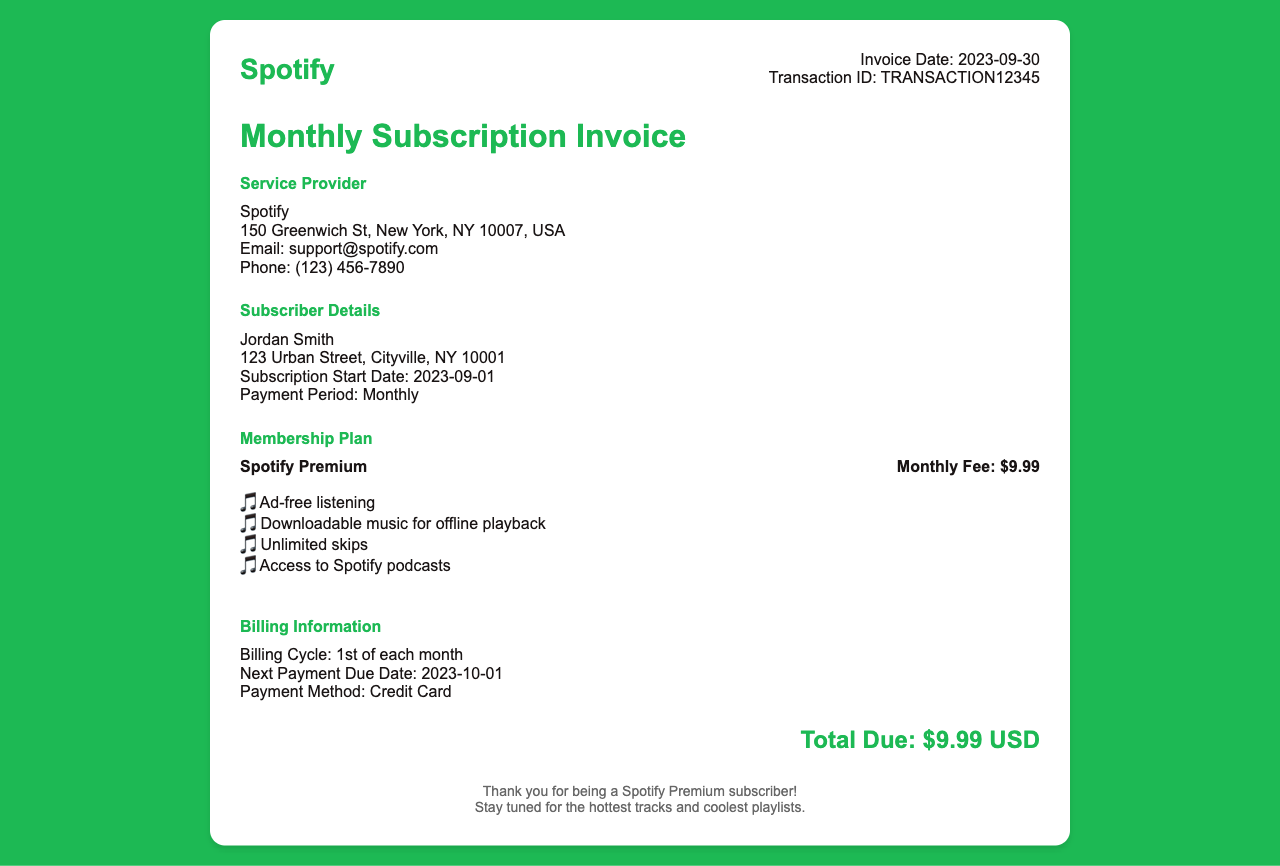What is the invoice date? The invoice date is clearly stated in the document as the date when the invoice was generated.
Answer: 2023-09-30 Who is the subscriber? The subscriber's name is mentioned in the document, indicating who the invoice is for.
Answer: Jordan Smith What is the next payment due date? The next payment due date is specified in the billing information section, showing when the payment is expected.
Answer: 2023-10-01 What is the monthly fee for the membership plan? The membership plan includes a monthly fee, which is listed in the document for subscription costs.
Answer: $9.99 What are two features of the Spotify Premium plan? The document lists several features of the Spotify Premium plan, indicating what subscribers can enjoy with their plan.
Answer: Ad-free listening, Downloadable music for offline playback What payment method is used? The payment method for the subscription is described in the billing information.
Answer: Credit Card When does the billing cycle start? The document mentions when the billing cycle begins, providing information on the recurring charges for the service.
Answer: 1st of each month What are the contact details for Spotify support? The document provides contact information for the service provider, indicating how subscribers can reach support if needed.
Answer: support@spotify.com, (123) 456-7890 